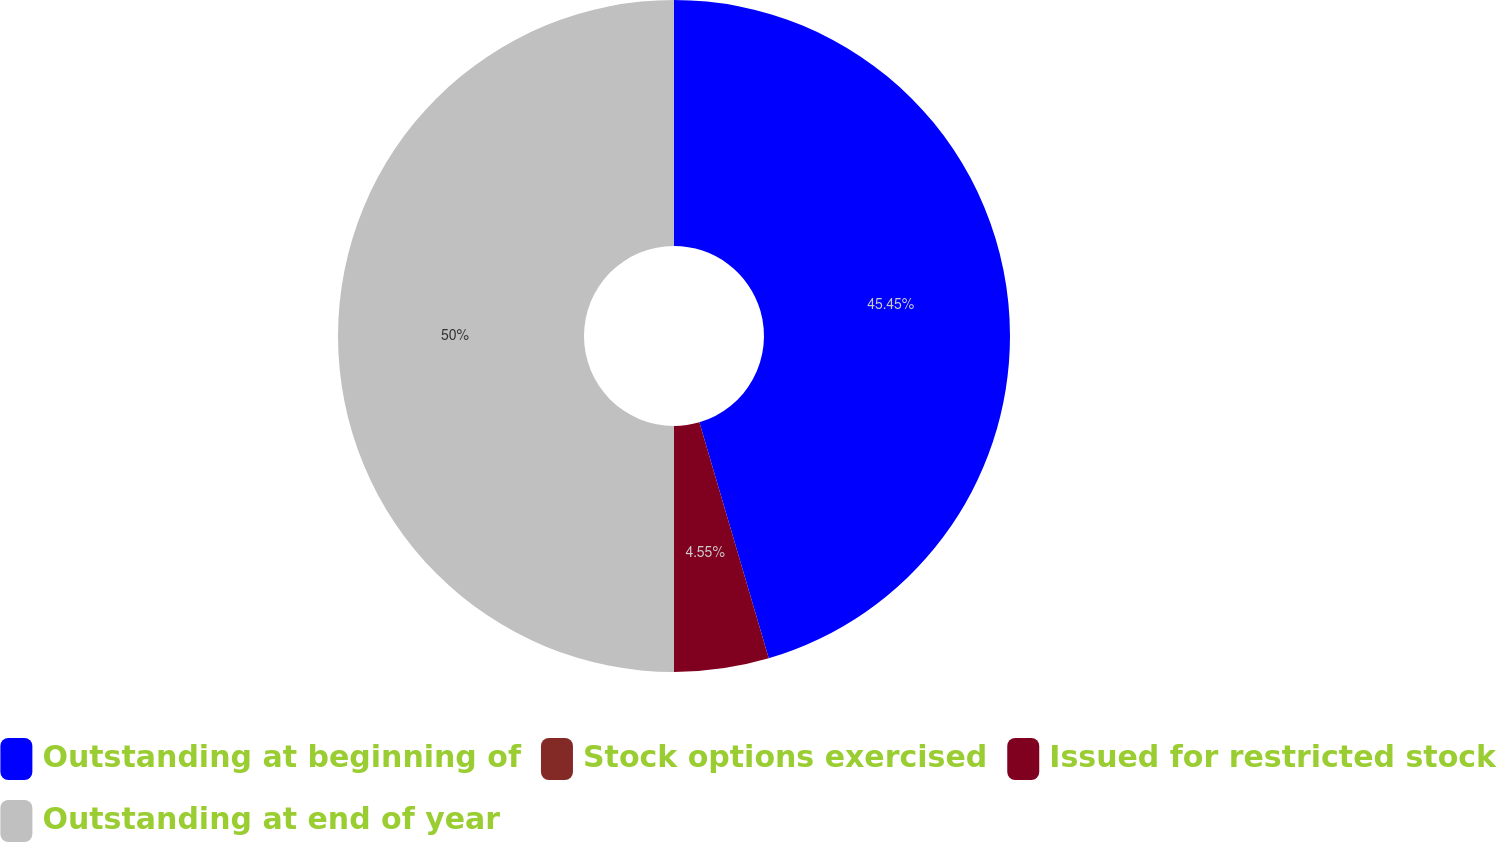Convert chart. <chart><loc_0><loc_0><loc_500><loc_500><pie_chart><fcel>Outstanding at beginning of<fcel>Stock options exercised<fcel>Issued for restricted stock<fcel>Outstanding at end of year<nl><fcel>45.45%<fcel>0.0%<fcel>4.55%<fcel>50.0%<nl></chart> 